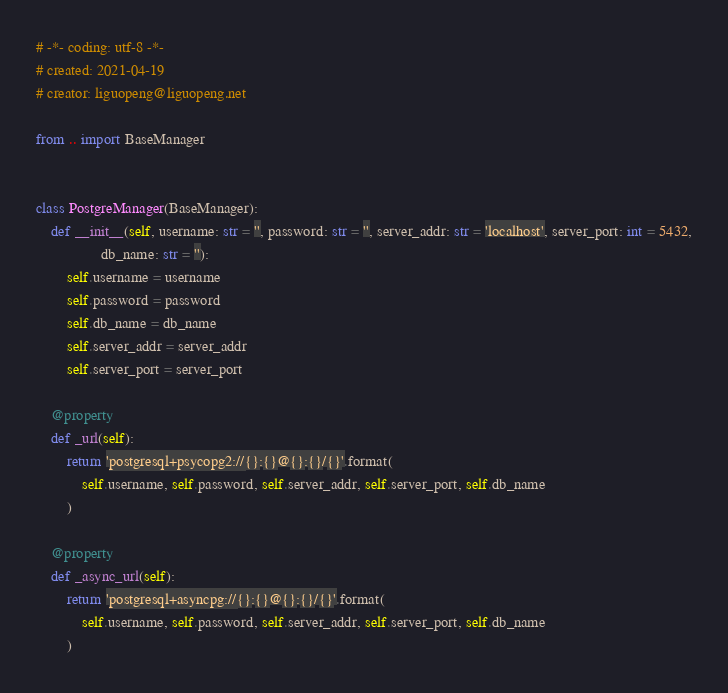<code> <loc_0><loc_0><loc_500><loc_500><_Python_># -*- coding: utf-8 -*- 
# created: 2021-04-19
# creator: liguopeng@liguopeng.net

from .. import BaseManager


class PostgreManager(BaseManager):
    def __init__(self, username: str = '', password: str = '', server_addr: str = 'localhost', server_port: int = 5432,
                 db_name: str = ''):
        self.username = username
        self.password = password
        self.db_name = db_name
        self.server_addr = server_addr
        self.server_port = server_port

    @property
    def _url(self):
        return 'postgresql+psycopg2://{}:{}@{}:{}/{}'.format(
            self.username, self.password, self.server_addr, self.server_port, self.db_name
        )

    @property
    def _async_url(self):
        return 'postgresql+asyncpg://{}:{}@{}:{}/{}'.format(
            self.username, self.password, self.server_addr, self.server_port, self.db_name
        )
</code> 